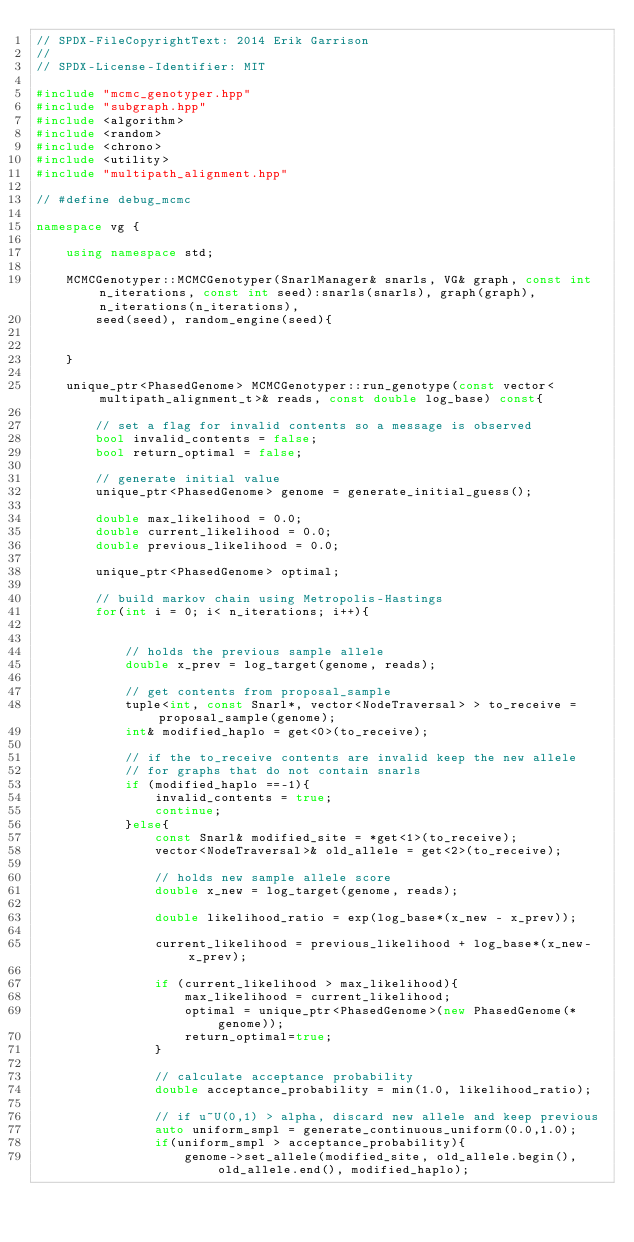<code> <loc_0><loc_0><loc_500><loc_500><_C++_>// SPDX-FileCopyrightText: 2014 Erik Garrison
//
// SPDX-License-Identifier: MIT

#include "mcmc_genotyper.hpp"
#include "subgraph.hpp"
#include <algorithm> 
#include <random> 
#include <chrono>
#include <utility>
#include "multipath_alignment.hpp"

// #define debug_mcmc

namespace vg {

    using namespace std;

    MCMCGenotyper::MCMCGenotyper(SnarlManager& snarls, VG& graph, const int n_iterations, const int seed):snarls(snarls), graph(graph), n_iterations(n_iterations), 
        seed(seed), random_engine(seed){
            
    
    }

    unique_ptr<PhasedGenome> MCMCGenotyper::run_genotype(const vector<multipath_alignment_t>& reads, const double log_base) const{

        // set a flag for invalid contents so a message is observed 
        bool invalid_contents = false;
        bool return_optimal = false;

        // generate initial value
        unique_ptr<PhasedGenome> genome = generate_initial_guess();
        
        double max_likelihood = 0.0; 
        double current_likelihood = 0.0; 
        double previous_likelihood = 0.0;
 
        unique_ptr<PhasedGenome> optimal;
        
        // build markov chain using Metropolis-Hastings
        for(int i = 0; i< n_iterations; i++){

            
            // holds the previous sample allele
            double x_prev = log_target(genome, reads);

            // get contents from proposal_sample
            tuple<int, const Snarl*, vector<NodeTraversal> > to_receive = proposal_sample(genome);
            int& modified_haplo = get<0>(to_receive);         
            
            // if the to_receive contents are invalid keep the new allele
            // for graphs that do not contain snarls
            if (modified_haplo ==-1){
                invalid_contents = true;
                continue;
            }else{
                const Snarl& modified_site = *get<1>(to_receive); 
                vector<NodeTraversal>& old_allele = get<2>(to_receive); 
 
                // holds new sample allele score 
                double x_new = log_target(genome, reads);

                double likelihood_ratio = exp(log_base*(x_new - x_prev));
                
                current_likelihood = previous_likelihood + log_base*(x_new-x_prev);
                
                if (current_likelihood > max_likelihood){
                    max_likelihood = current_likelihood;
                    optimal = unique_ptr<PhasedGenome>(new PhasedGenome(*genome));
                    return_optimal=true;
                }
                
                // calculate acceptance probability 
                double acceptance_probability = min(1.0, likelihood_ratio);

                // if u~U(0,1) > alpha, discard new allele and keep previous 
                auto uniform_smpl = generate_continuous_uniform(0.0,1.0);
                if(uniform_smpl > acceptance_probability){ 
                    genome->set_allele(modified_site, old_allele.begin(), old_allele.end(), modified_haplo); </code> 